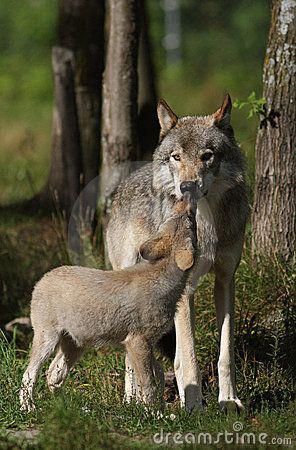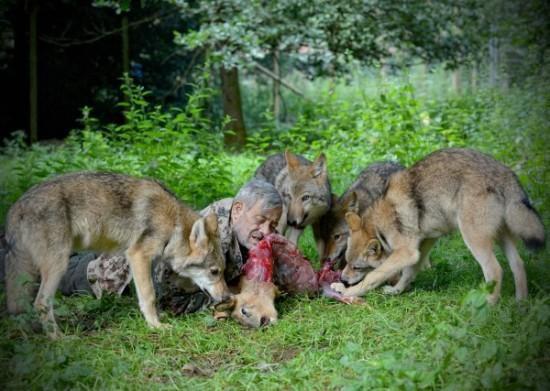The first image is the image on the left, the second image is the image on the right. For the images shown, is this caption "The left image contains exactly one wolf." true? Answer yes or no. No. The first image is the image on the left, the second image is the image on the right. Considering the images on both sides, is "There is only one wolf in at least one of the images." valid? Answer yes or no. No. 